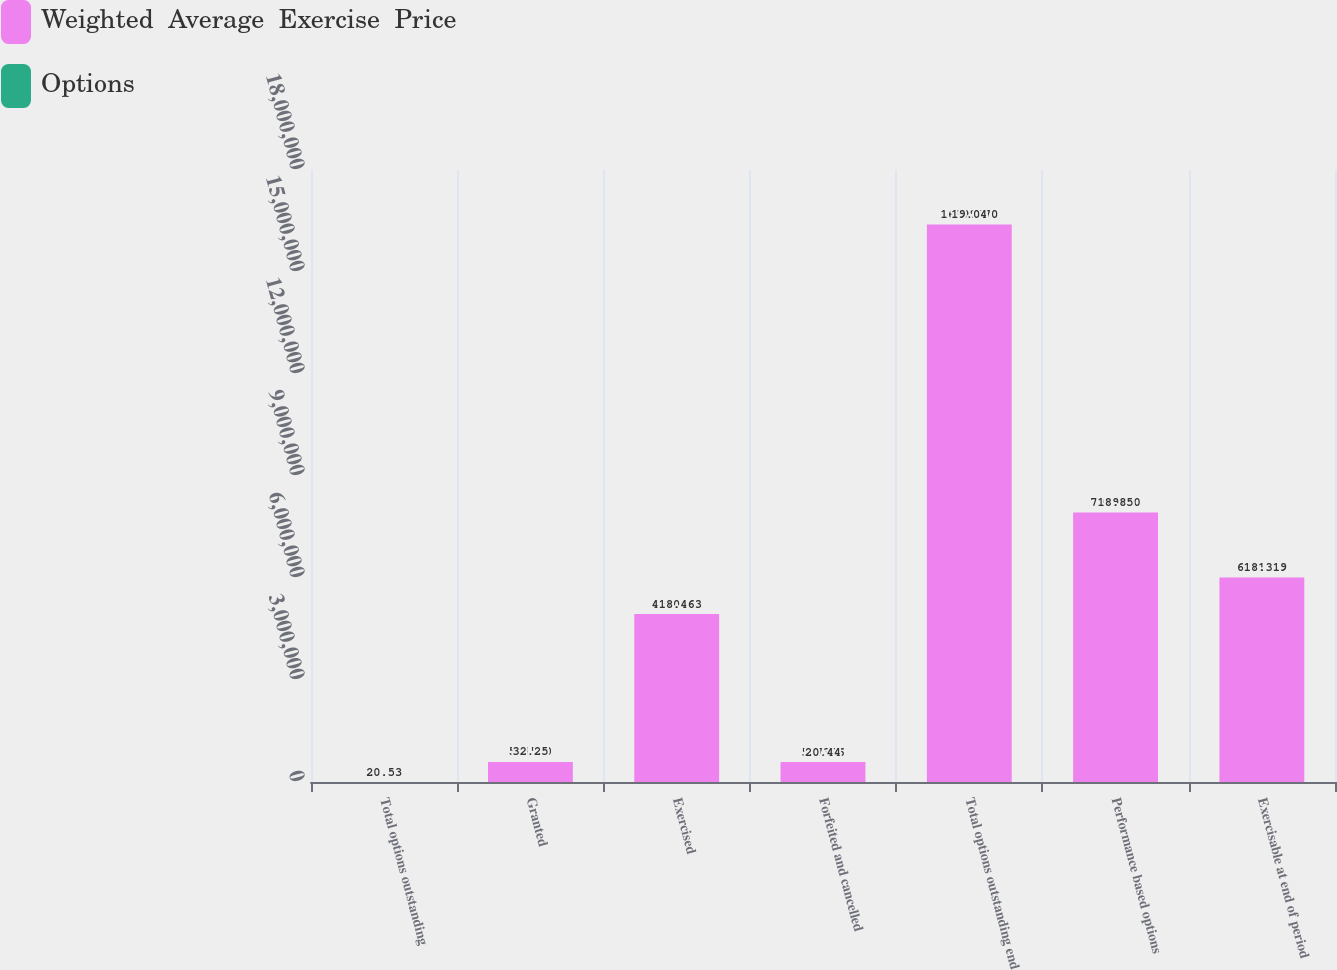Convert chart. <chart><loc_0><loc_0><loc_500><loc_500><stacked_bar_chart><ecel><fcel>Total options outstanding<fcel>Granted<fcel>Exercised<fcel>Forfeited and cancelled<fcel>Total options outstanding end<fcel>Performance based options<fcel>Exercisable at end of period<nl><fcel>Weighted  Average  Exercise  Price<fcel>32.25<fcel>591500<fcel>4.94039e+06<fcel>587396<fcel>1.63999e+07<fcel>7.92925e+06<fcel>6.01172e+06<nl><fcel>Options<fcel>20.53<fcel>32.25<fcel>18.46<fcel>20.44<fcel>19.04<fcel>18.85<fcel>18.31<nl></chart> 